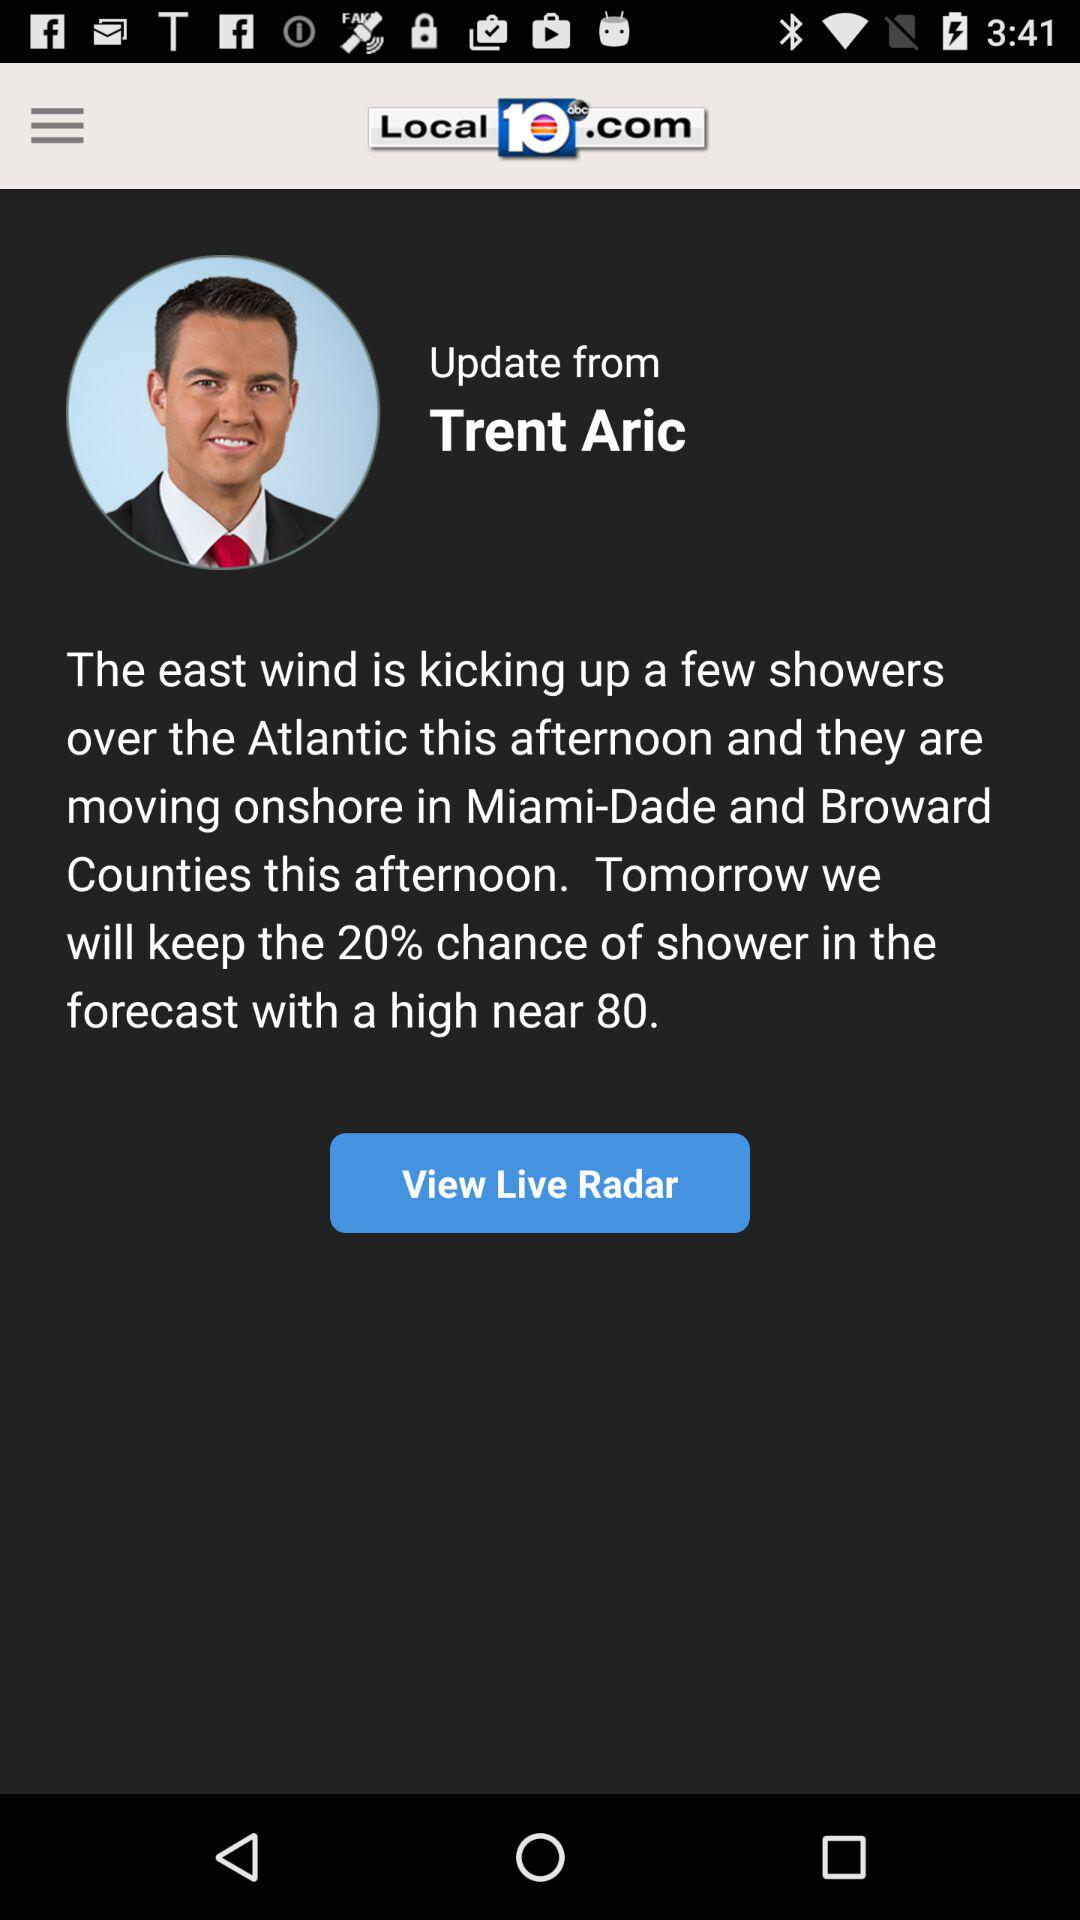How many sentences does the text have?
Answer the question using a single word or phrase. 2 